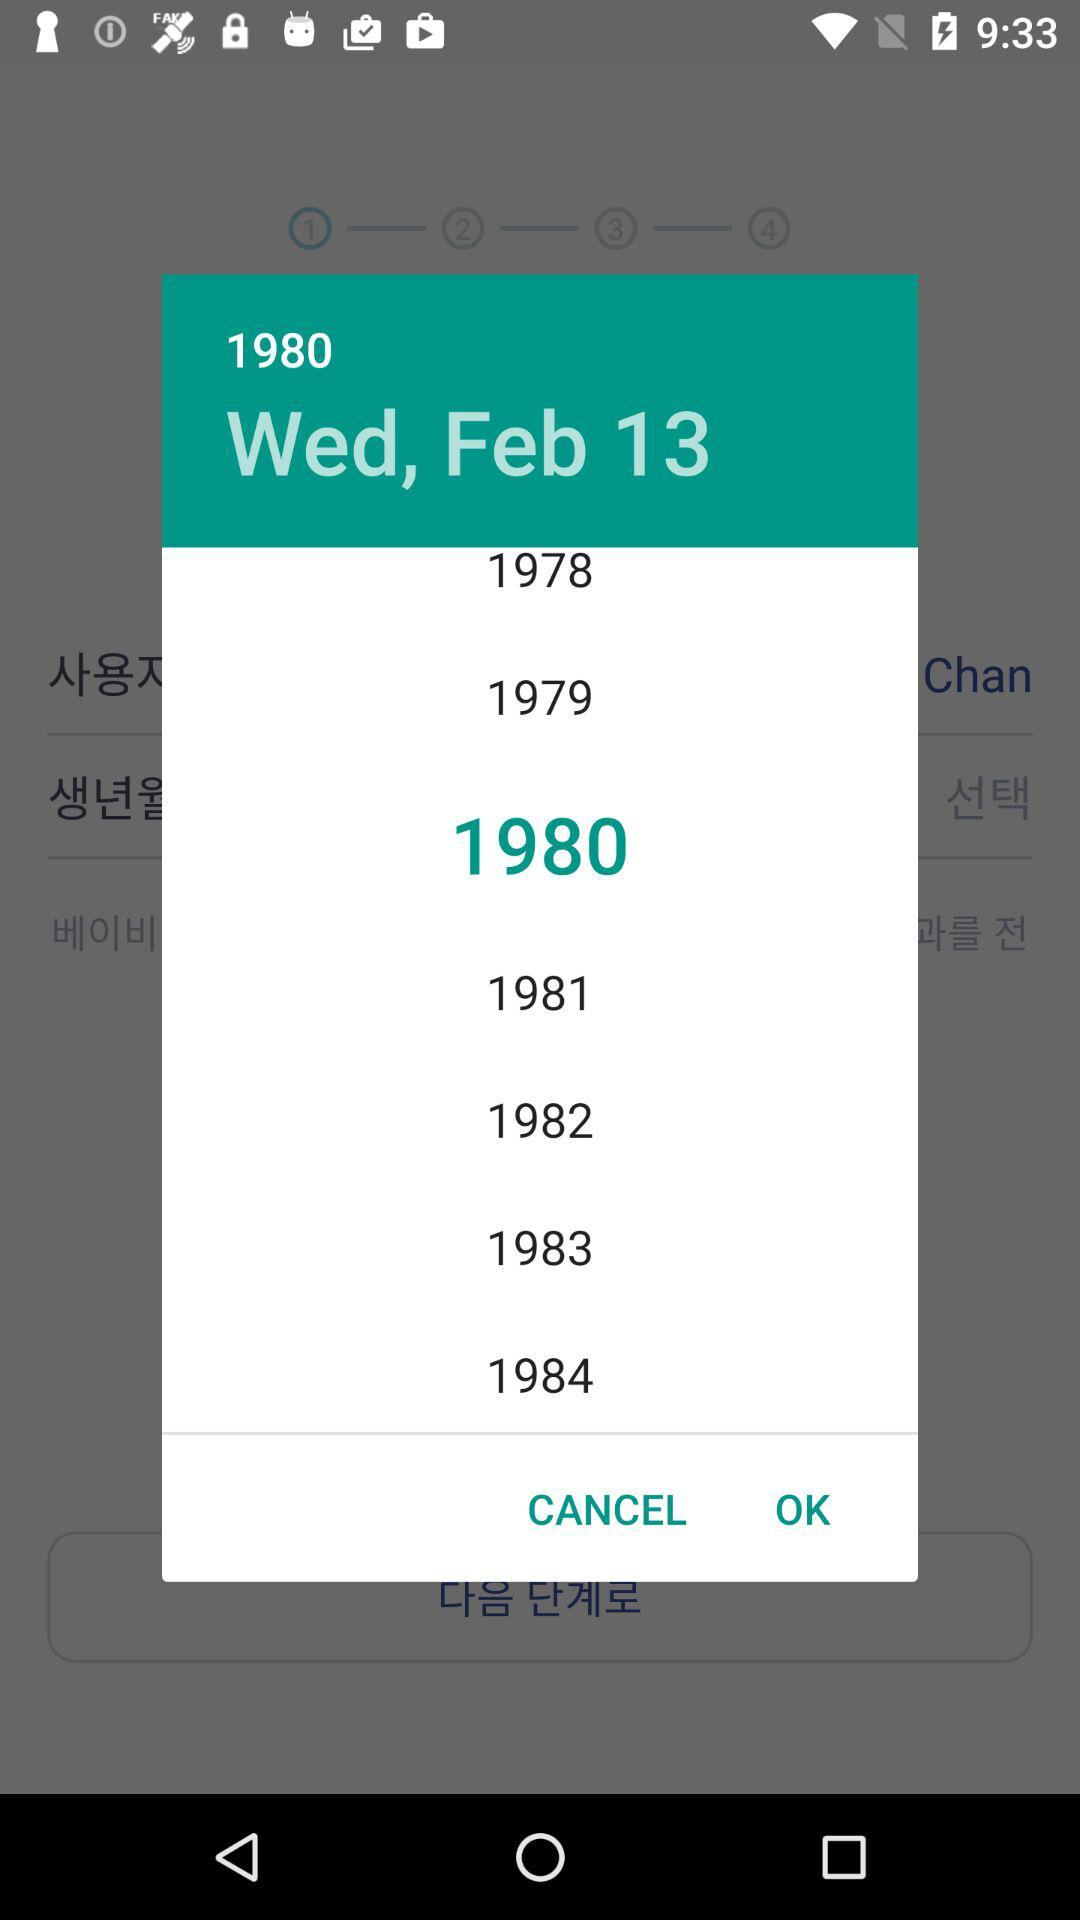What is the shown date? The shown date is Wednesday, February 13, 1980. 